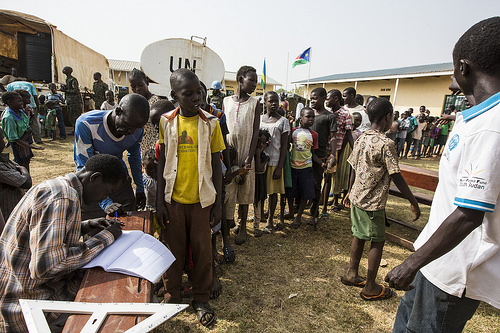<image>
Can you confirm if the man is in front of the guy? Yes. The man is positioned in front of the guy, appearing closer to the camera viewpoint. Is the man in front of the boy? No. The man is not in front of the boy. The spatial positioning shows a different relationship between these objects. 